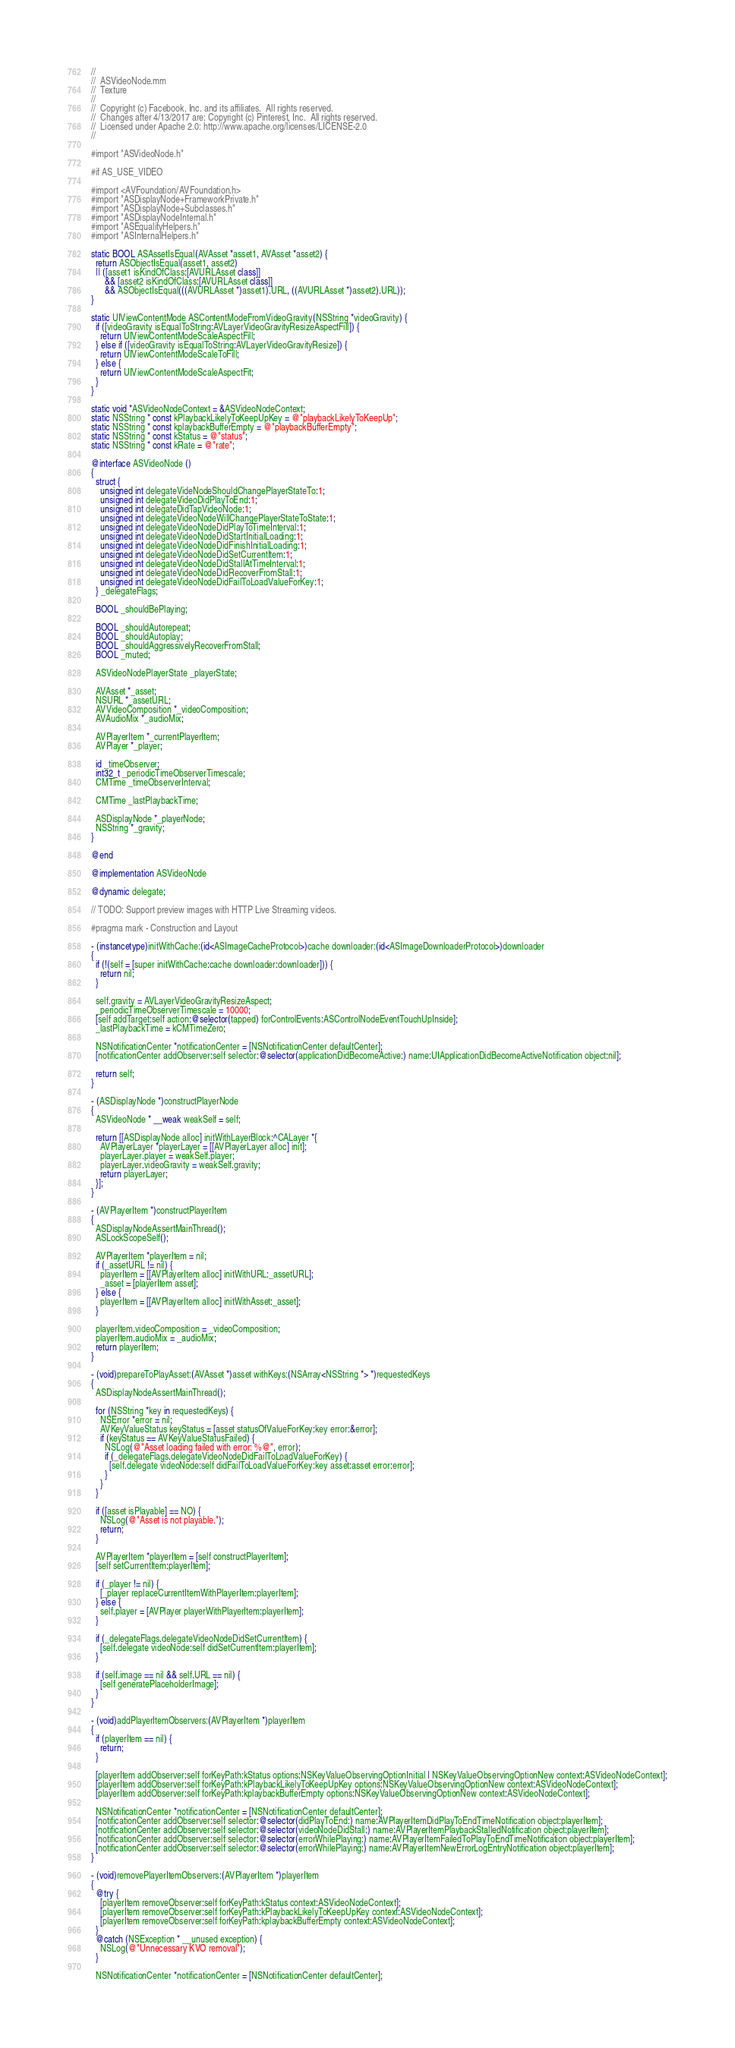Convert code to text. <code><loc_0><loc_0><loc_500><loc_500><_ObjectiveC_>//
//  ASVideoNode.mm
//  Texture
//
//  Copyright (c) Facebook, Inc. and its affiliates.  All rights reserved.
//  Changes after 4/13/2017 are: Copyright (c) Pinterest, Inc.  All rights reserved.
//  Licensed under Apache 2.0: http://www.apache.org/licenses/LICENSE-2.0
//

#import "ASVideoNode.h"

#if AS_USE_VIDEO

#import <AVFoundation/AVFoundation.h>
#import "ASDisplayNode+FrameworkPrivate.h"
#import "ASDisplayNode+Subclasses.h"
#import "ASDisplayNodeInternal.h"
#import "ASEqualityHelpers.h"
#import "ASInternalHelpers.h"

static BOOL ASAssetIsEqual(AVAsset *asset1, AVAsset *asset2) {
  return ASObjectIsEqual(asset1, asset2)
  || ([asset1 isKindOfClass:[AVURLAsset class]]
      && [asset2 isKindOfClass:[AVURLAsset class]]
      && ASObjectIsEqual(((AVURLAsset *)asset1).URL, ((AVURLAsset *)asset2).URL));
}

static UIViewContentMode ASContentModeFromVideoGravity(NSString *videoGravity) {
  if ([videoGravity isEqualToString:AVLayerVideoGravityResizeAspectFill]) {
    return UIViewContentModeScaleAspectFill;
  } else if ([videoGravity isEqualToString:AVLayerVideoGravityResize]) {
    return UIViewContentModeScaleToFill;
  } else {
    return UIViewContentModeScaleAspectFit;
  }
}

static void *ASVideoNodeContext = &ASVideoNodeContext;
static NSString * const kPlaybackLikelyToKeepUpKey = @"playbackLikelyToKeepUp";
static NSString * const kplaybackBufferEmpty = @"playbackBufferEmpty";
static NSString * const kStatus = @"status";
static NSString * const kRate = @"rate";

@interface ASVideoNode ()
{
  struct {
    unsigned int delegateVideNodeShouldChangePlayerStateTo:1;
    unsigned int delegateVideoDidPlayToEnd:1;
    unsigned int delegateDidTapVideoNode:1;
    unsigned int delegateVideoNodeWillChangePlayerStateToState:1;
    unsigned int delegateVideoNodeDidPlayToTimeInterval:1;
    unsigned int delegateVideoNodeDidStartInitialLoading:1;
    unsigned int delegateVideoNodeDidFinishInitialLoading:1;
    unsigned int delegateVideoNodeDidSetCurrentItem:1;
    unsigned int delegateVideoNodeDidStallAtTimeInterval:1;
    unsigned int delegateVideoNodeDidRecoverFromStall:1;
    unsigned int delegateVideoNodeDidFailToLoadValueForKey:1;
  } _delegateFlags;
  
  BOOL _shouldBePlaying;
  
  BOOL _shouldAutorepeat;
  BOOL _shouldAutoplay;
  BOOL _shouldAggressivelyRecoverFromStall;
  BOOL _muted;
  
  ASVideoNodePlayerState _playerState;
  
  AVAsset *_asset;
  NSURL *_assetURL;
  AVVideoComposition *_videoComposition;
  AVAudioMix *_audioMix;
  
  AVPlayerItem *_currentPlayerItem;
  AVPlayer *_player;
  
  id _timeObserver;
  int32_t _periodicTimeObserverTimescale;
  CMTime _timeObserverInterval;
  
  CMTime _lastPlaybackTime;
	
  ASDisplayNode *_playerNode;
  NSString *_gravity;
}

@end

@implementation ASVideoNode

@dynamic delegate;

// TODO: Support preview images with HTTP Live Streaming videos.

#pragma mark - Construction and Layout

- (instancetype)initWithCache:(id<ASImageCacheProtocol>)cache downloader:(id<ASImageDownloaderProtocol>)downloader
{
  if (!(self = [super initWithCache:cache downloader:downloader])) {
    return nil;
  }

  self.gravity = AVLayerVideoGravityResizeAspect;
  _periodicTimeObserverTimescale = 10000;
  [self addTarget:self action:@selector(tapped) forControlEvents:ASControlNodeEventTouchUpInside];
  _lastPlaybackTime = kCMTimeZero;
  
  NSNotificationCenter *notificationCenter = [NSNotificationCenter defaultCenter];
  [notificationCenter addObserver:self selector:@selector(applicationDidBecomeActive:) name:UIApplicationDidBecomeActiveNotification object:nil];
  
  return self;
}

- (ASDisplayNode *)constructPlayerNode
{
  ASVideoNode * __weak weakSelf = self;

  return [[ASDisplayNode alloc] initWithLayerBlock:^CALayer *{
    AVPlayerLayer *playerLayer = [[AVPlayerLayer alloc] init];
    playerLayer.player = weakSelf.player;
    playerLayer.videoGravity = weakSelf.gravity;
    return playerLayer;
  }];
}

- (AVPlayerItem *)constructPlayerItem
{
  ASDisplayNodeAssertMainThread();
  ASLockScopeSelf();

  AVPlayerItem *playerItem = nil;
  if (_assetURL != nil) {
    playerItem = [[AVPlayerItem alloc] initWithURL:_assetURL];
    _asset = [playerItem asset];
  } else {
    playerItem = [[AVPlayerItem alloc] initWithAsset:_asset];
  }

  playerItem.videoComposition = _videoComposition;
  playerItem.audioMix = _audioMix;
  return playerItem;
}

- (void)prepareToPlayAsset:(AVAsset *)asset withKeys:(NSArray<NSString *> *)requestedKeys
{
  ASDisplayNodeAssertMainThread();
  
  for (NSString *key in requestedKeys) {
    NSError *error = nil;
    AVKeyValueStatus keyStatus = [asset statusOfValueForKey:key error:&error];
    if (keyStatus == AVKeyValueStatusFailed) {
      NSLog(@"Asset loading failed with error: %@", error);
      if (_delegateFlags.delegateVideoNodeDidFailToLoadValueForKey) {
        [self.delegate videoNode:self didFailToLoadValueForKey:key asset:asset error:error];
      }
    }
  }
  
  if ([asset isPlayable] == NO) {
    NSLog(@"Asset is not playable.");
    return;
  }

  AVPlayerItem *playerItem = [self constructPlayerItem];
  [self setCurrentItem:playerItem];
  
  if (_player != nil) {
    [_player replaceCurrentItemWithPlayerItem:playerItem];
  } else {
    self.player = [AVPlayer playerWithPlayerItem:playerItem];
  }

  if (_delegateFlags.delegateVideoNodeDidSetCurrentItem) {
    [self.delegate videoNode:self didSetCurrentItem:playerItem];
  }

  if (self.image == nil && self.URL == nil) {
    [self generatePlaceholderImage];
  }
}

- (void)addPlayerItemObservers:(AVPlayerItem *)playerItem
{
  if (playerItem == nil) {
    return;
  }
  
  [playerItem addObserver:self forKeyPath:kStatus options:NSKeyValueObservingOptionInitial | NSKeyValueObservingOptionNew context:ASVideoNodeContext];
  [playerItem addObserver:self forKeyPath:kPlaybackLikelyToKeepUpKey options:NSKeyValueObservingOptionNew context:ASVideoNodeContext];
  [playerItem addObserver:self forKeyPath:kplaybackBufferEmpty options:NSKeyValueObservingOptionNew context:ASVideoNodeContext];
  
  NSNotificationCenter *notificationCenter = [NSNotificationCenter defaultCenter];
  [notificationCenter addObserver:self selector:@selector(didPlayToEnd:) name:AVPlayerItemDidPlayToEndTimeNotification object:playerItem];
  [notificationCenter addObserver:self selector:@selector(videoNodeDidStall:) name:AVPlayerItemPlaybackStalledNotification object:playerItem];
  [notificationCenter addObserver:self selector:@selector(errorWhilePlaying:) name:AVPlayerItemFailedToPlayToEndTimeNotification object:playerItem];
  [notificationCenter addObserver:self selector:@selector(errorWhilePlaying:) name:AVPlayerItemNewErrorLogEntryNotification object:playerItem];
}

- (void)removePlayerItemObservers:(AVPlayerItem *)playerItem
{
  @try {
    [playerItem removeObserver:self forKeyPath:kStatus context:ASVideoNodeContext];
    [playerItem removeObserver:self forKeyPath:kPlaybackLikelyToKeepUpKey context:ASVideoNodeContext];
    [playerItem removeObserver:self forKeyPath:kplaybackBufferEmpty context:ASVideoNodeContext];
  }
  @catch (NSException * __unused exception) {
    NSLog(@"Unnecessary KVO removal");
  }

  NSNotificationCenter *notificationCenter = [NSNotificationCenter defaultCenter];</code> 